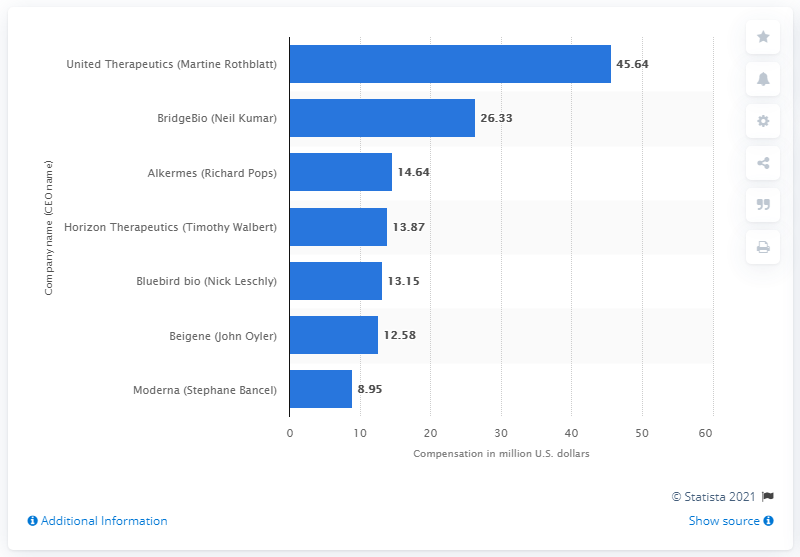Draw attention to some important aspects in this diagram. The compensation received by Martine Rothblatt is 45.64. 